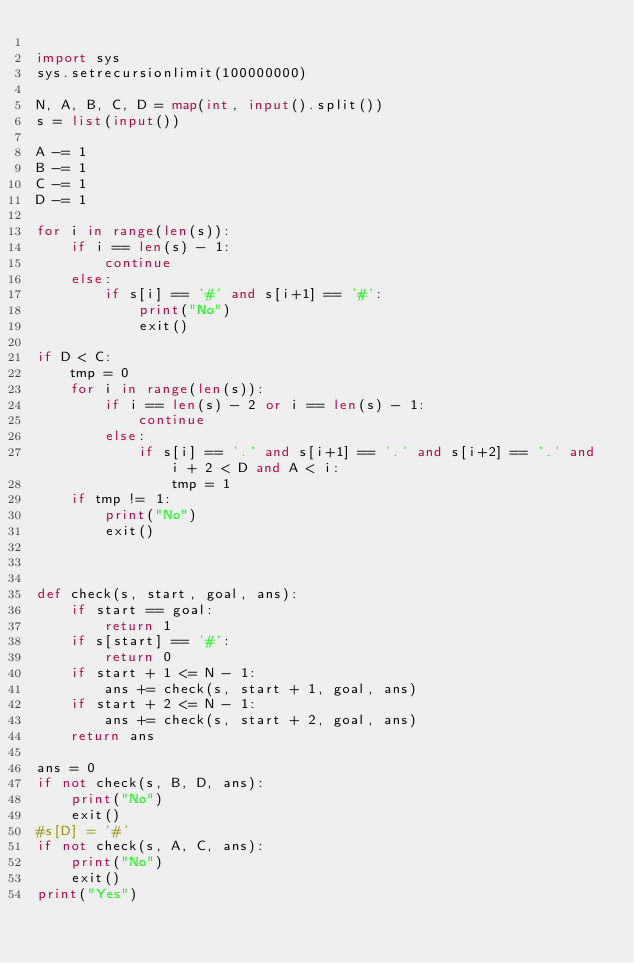<code> <loc_0><loc_0><loc_500><loc_500><_Python_>
import sys
sys.setrecursionlimit(100000000)

N, A, B, C, D = map(int, input().split())
s = list(input())

A -= 1
B -= 1
C -= 1
D -= 1

for i in range(len(s)):
    if i == len(s) - 1:
        continue
    else:
        if s[i] == '#' and s[i+1] == '#':
            print("No")
            exit()

if D < C:
    tmp = 0
    for i in range(len(s)):
        if i == len(s) - 2 or i == len(s) - 1:
            continue
        else:
            if s[i] == '.' and s[i+1] == '.' and s[i+2] == '.' and i + 2 < D and A < i:
                tmp = 1
    if tmp != 1:
        print("No")
        exit()



def check(s, start, goal, ans):
    if start == goal:
        return 1
    if s[start] == '#':
        return 0
    if start + 1 <= N - 1:
        ans += check(s, start + 1, goal, ans)
    if start + 2 <= N - 1:
        ans += check(s, start + 2, goal, ans)
    return ans

ans = 0
if not check(s, B, D, ans):
    print("No")
    exit()
#s[D] = '#'
if not check(s, A, C, ans):
    print("No")
    exit()
print("Yes")</code> 